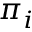Convert formula to latex. <formula><loc_0><loc_0><loc_500><loc_500>\pi _ { i }</formula> 